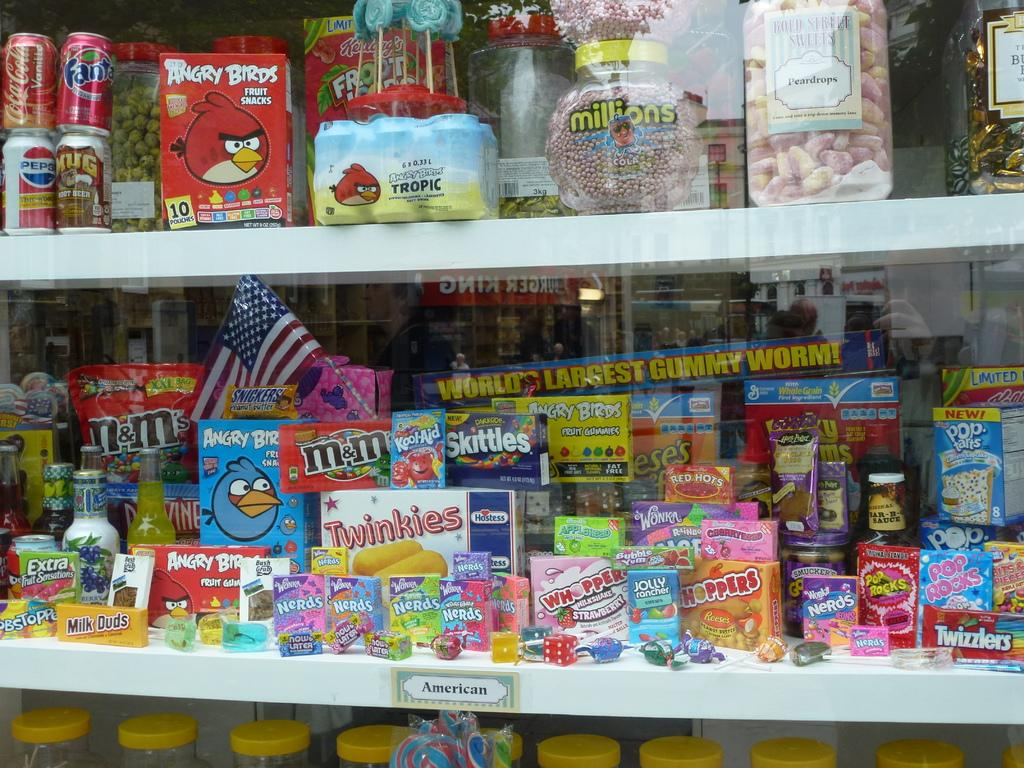Provide a one-sentence caption for the provided image. a shelf with candies on it that is labeled 'american'. 